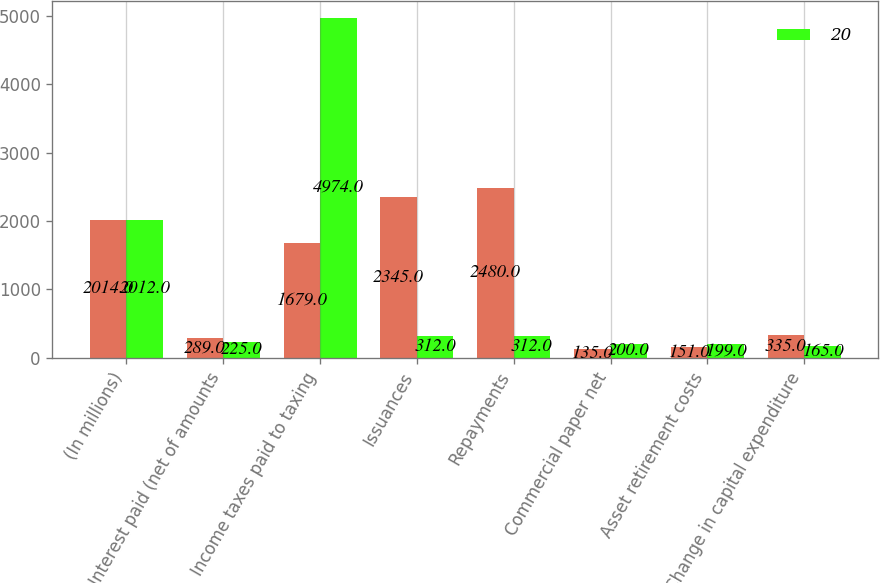<chart> <loc_0><loc_0><loc_500><loc_500><stacked_bar_chart><ecel><fcel>(In millions)<fcel>Interest paid (net of amounts<fcel>Income taxes paid to taxing<fcel>Issuances<fcel>Repayments<fcel>Commercial paper net<fcel>Asset retirement costs<fcel>Change in capital expenditure<nl><fcel>nan<fcel>2014<fcel>289<fcel>1679<fcel>2345<fcel>2480<fcel>135<fcel>151<fcel>335<nl><fcel>20<fcel>2012<fcel>225<fcel>4974<fcel>312<fcel>312<fcel>200<fcel>199<fcel>165<nl></chart> 